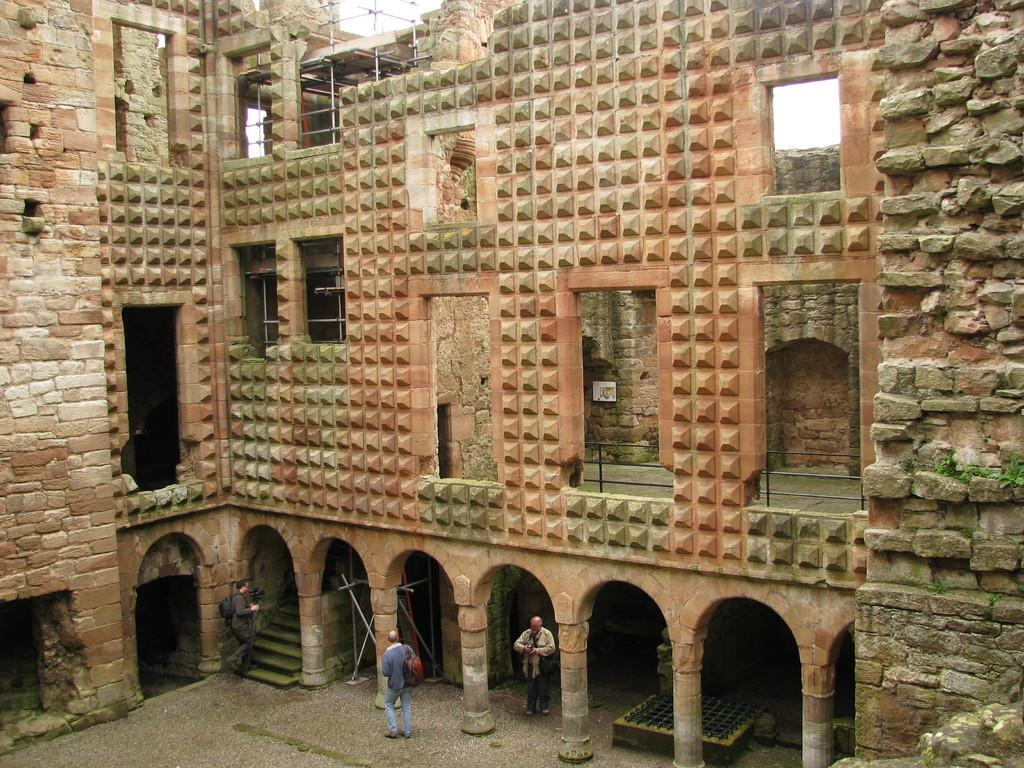How many people are present in the image? There are three persons in the image. What type of structure can be seen in the image? There is a building in the image. Are there any architectural features visible in the image? Yes, there are pillars in the image. What type of stem can be seen growing from the grape in the image? There is no grape or stem present in the image. How many mint leaves are visible on the persons in the image? There are no mint leaves visible on the persons in the image. 